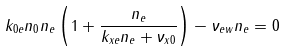Convert formula to latex. <formula><loc_0><loc_0><loc_500><loc_500>k _ { 0 e } n _ { 0 } n _ { e } \left ( 1 + \frac { n _ { e } } { k _ { x e } n _ { e } + \nu _ { x 0 } } \right ) - \nu _ { e w } n _ { e } = 0</formula> 